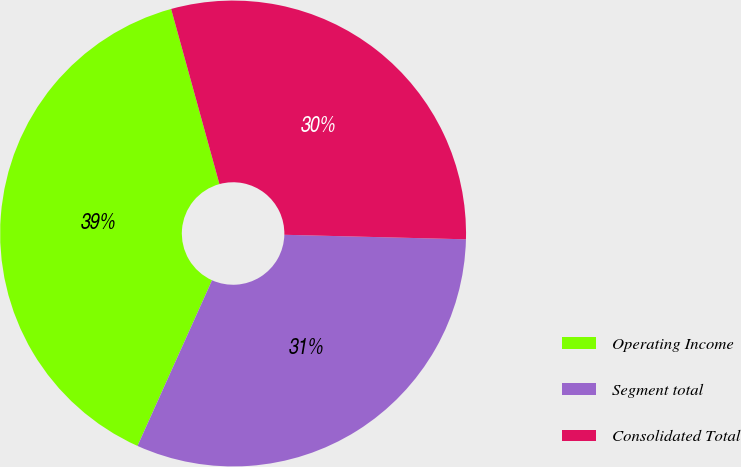<chart> <loc_0><loc_0><loc_500><loc_500><pie_chart><fcel>Operating Income<fcel>Segment total<fcel>Consolidated Total<nl><fcel>38.98%<fcel>31.33%<fcel>29.68%<nl></chart> 